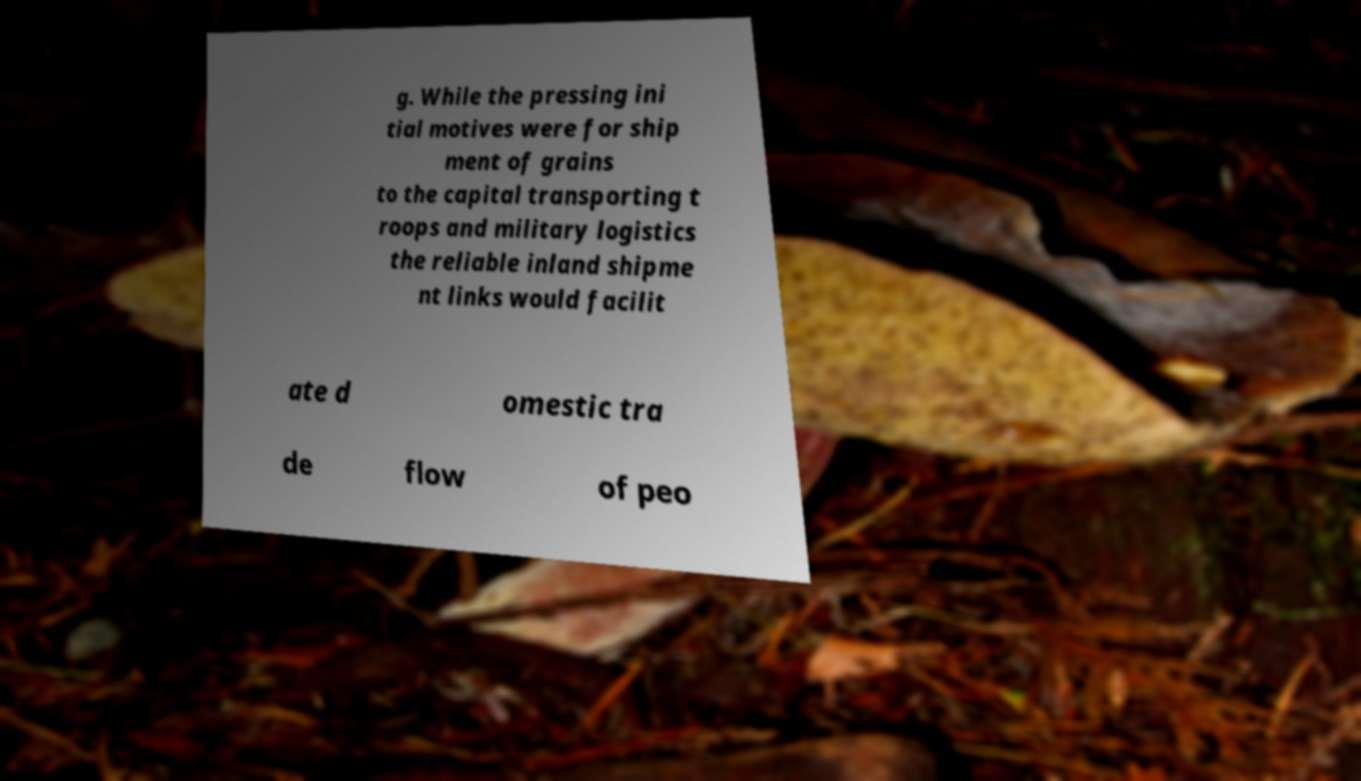Can you read and provide the text displayed in the image?This photo seems to have some interesting text. Can you extract and type it out for me? g. While the pressing ini tial motives were for ship ment of grains to the capital transporting t roops and military logistics the reliable inland shipme nt links would facilit ate d omestic tra de flow of peo 